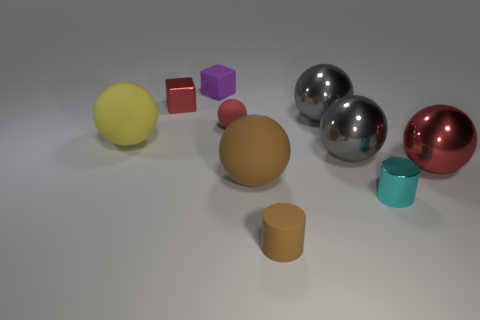Subtract all gray shiny balls. How many balls are left? 4 Subtract all red balls. How many balls are left? 4 Subtract 2 balls. How many balls are left? 4 Subtract all yellow spheres. Subtract all green cylinders. How many spheres are left? 5 Subtract all balls. How many objects are left? 4 Subtract 1 red cubes. How many objects are left? 9 Subtract all tiny metal cubes. Subtract all small red shiny cubes. How many objects are left? 8 Add 8 big gray shiny balls. How many big gray shiny balls are left? 10 Add 2 small red metal cylinders. How many small red metal cylinders exist? 2 